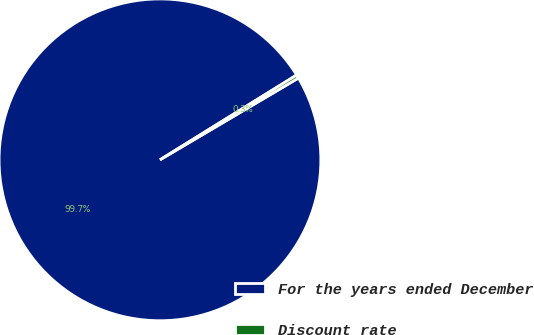Convert chart to OTSL. <chart><loc_0><loc_0><loc_500><loc_500><pie_chart><fcel>For the years ended December<fcel>Discount rate<nl><fcel>99.65%<fcel>0.35%<nl></chart> 